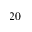Convert formula to latex. <formula><loc_0><loc_0><loc_500><loc_500>2 0</formula> 